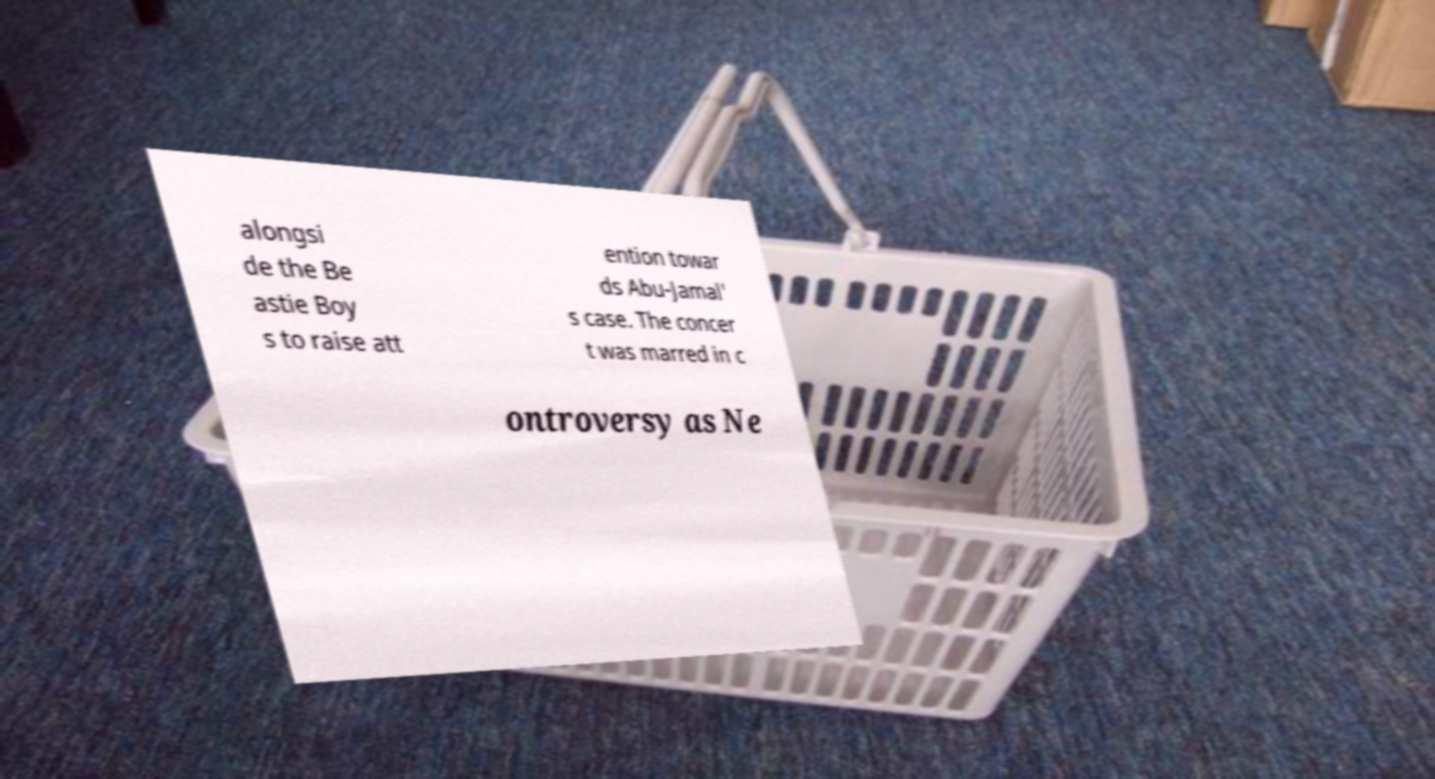For documentation purposes, I need the text within this image transcribed. Could you provide that? alongsi de the Be astie Boy s to raise att ention towar ds Abu-Jamal' s case. The concer t was marred in c ontroversy as Ne 